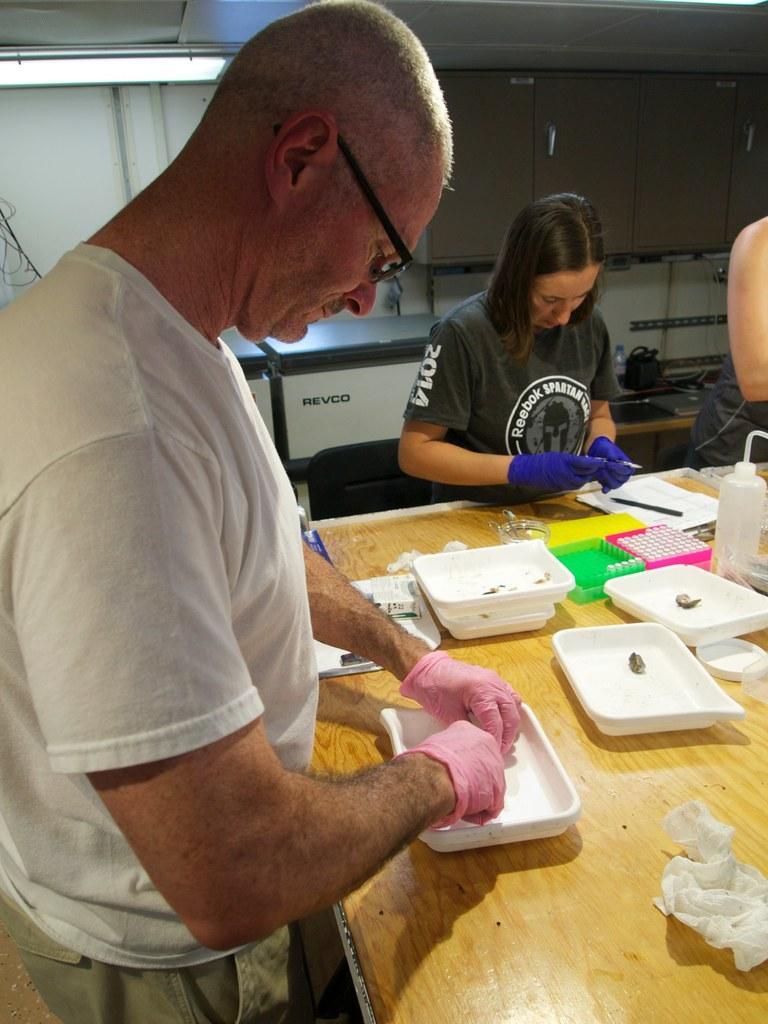Please provide a concise description of this image. In this image, we can see two people are standing near the wooden table and wearing gloves. Here we can see so many things, trays, bottle. Background there is a wall, cupboards, boxes, few objects. On the right side of the image, we can see the human body. 